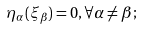<formula> <loc_0><loc_0><loc_500><loc_500>\eta _ { \alpha } ( \xi _ { \beta } ) = 0 , \forall \alpha \neq \beta ;</formula> 